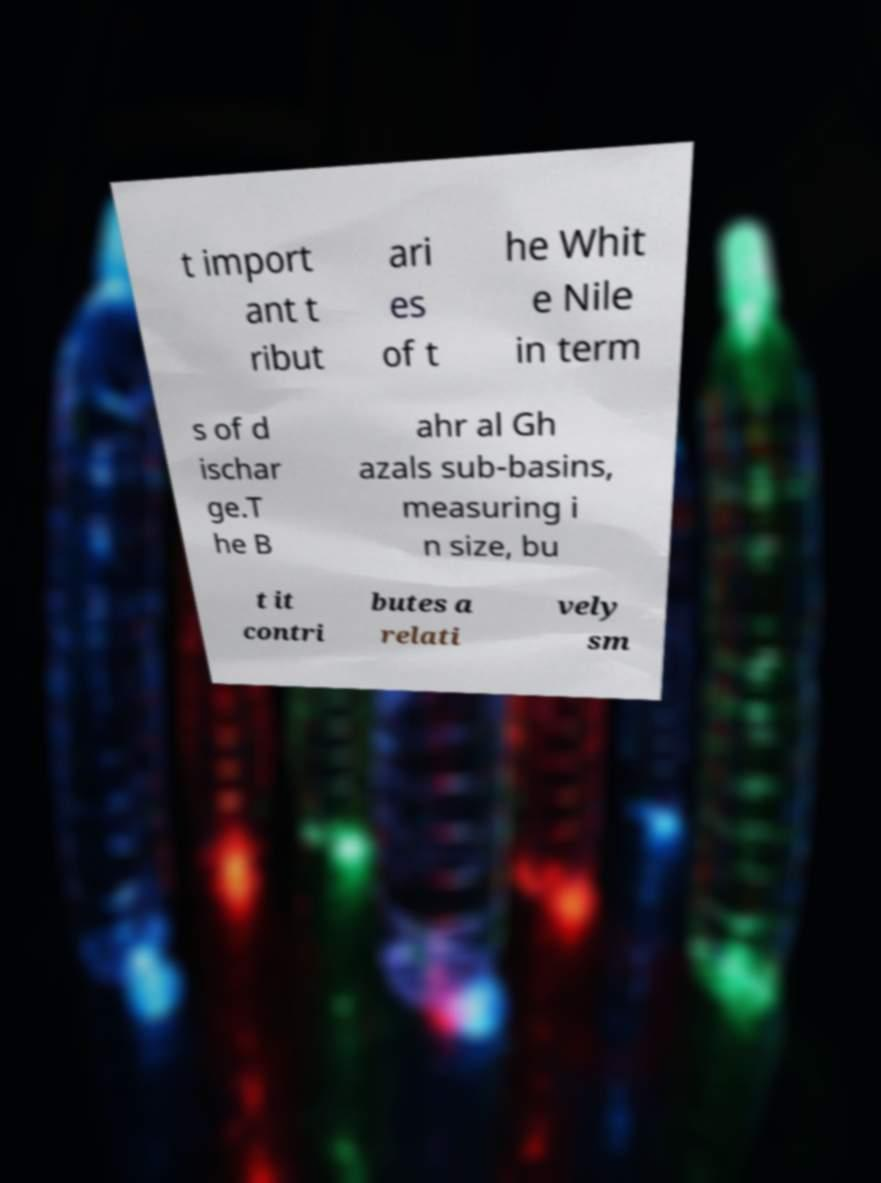Could you assist in decoding the text presented in this image and type it out clearly? t import ant t ribut ari es of t he Whit e Nile in term s of d ischar ge.T he B ahr al Gh azals sub-basins, measuring i n size, bu t it contri butes a relati vely sm 